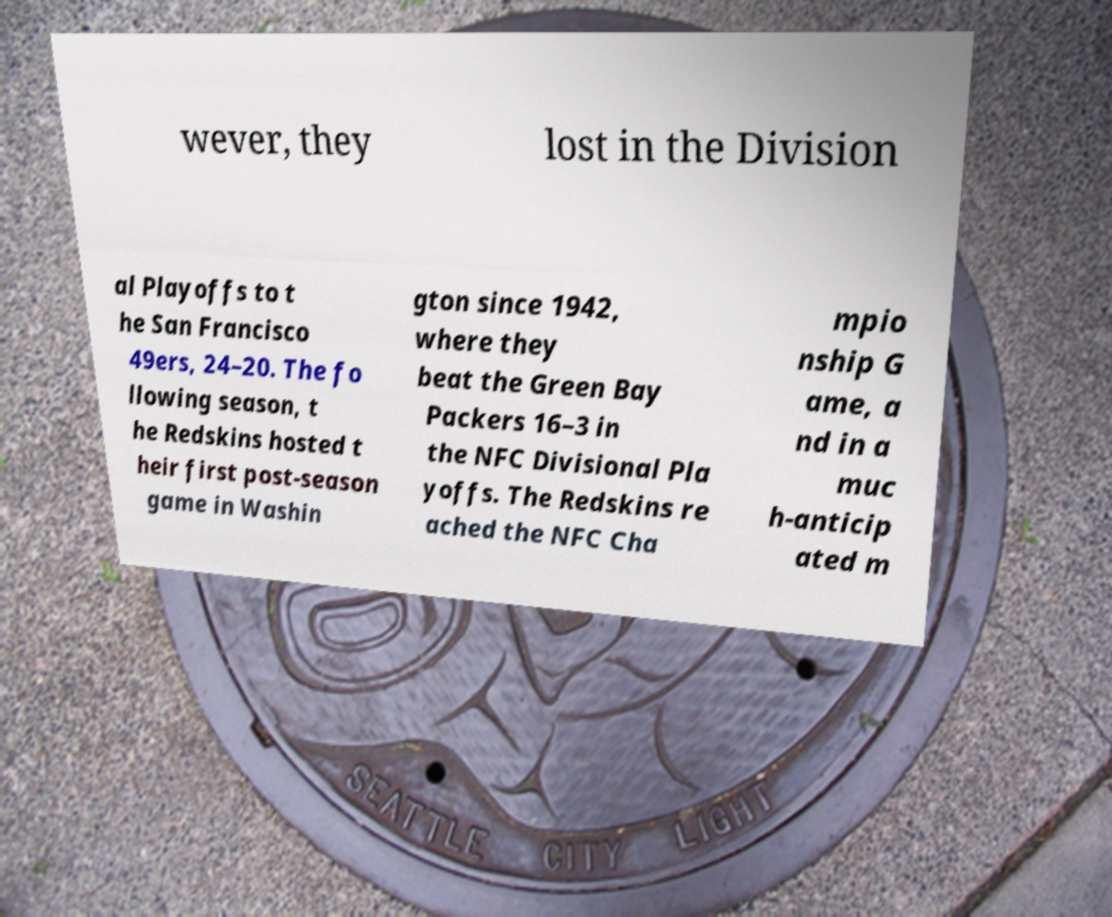Could you extract and type out the text from this image? wever, they lost in the Division al Playoffs to t he San Francisco 49ers, 24–20. The fo llowing season, t he Redskins hosted t heir first post-season game in Washin gton since 1942, where they beat the Green Bay Packers 16–3 in the NFC Divisional Pla yoffs. The Redskins re ached the NFC Cha mpio nship G ame, a nd in a muc h-anticip ated m 